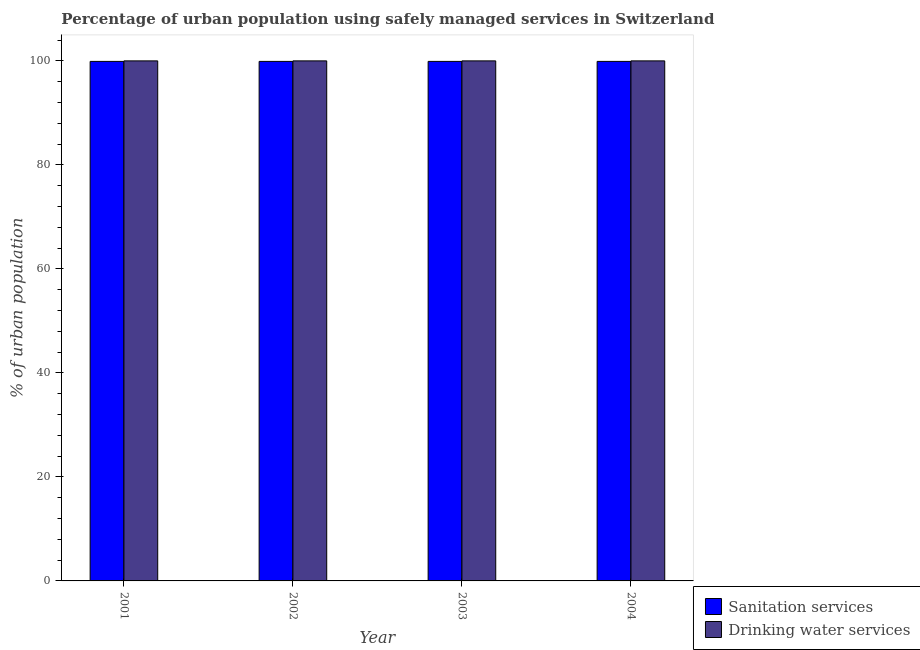How many bars are there on the 1st tick from the left?
Offer a very short reply. 2. What is the label of the 3rd group of bars from the left?
Make the answer very short. 2003. In how many cases, is the number of bars for a given year not equal to the number of legend labels?
Keep it short and to the point. 0. What is the percentage of urban population who used drinking water services in 2003?
Ensure brevity in your answer.  100. Across all years, what is the maximum percentage of urban population who used sanitation services?
Ensure brevity in your answer.  99.9. Across all years, what is the minimum percentage of urban population who used sanitation services?
Offer a terse response. 99.9. In which year was the percentage of urban population who used drinking water services minimum?
Ensure brevity in your answer.  2001. What is the total percentage of urban population who used drinking water services in the graph?
Keep it short and to the point. 400. What is the average percentage of urban population who used sanitation services per year?
Your answer should be very brief. 99.9. In how many years, is the percentage of urban population who used drinking water services greater than 40 %?
Your response must be concise. 4. Is the percentage of urban population who used drinking water services in 2001 less than that in 2003?
Keep it short and to the point. No. Is the difference between the percentage of urban population who used sanitation services in 2001 and 2004 greater than the difference between the percentage of urban population who used drinking water services in 2001 and 2004?
Give a very brief answer. No. What does the 2nd bar from the left in 2001 represents?
Provide a short and direct response. Drinking water services. What does the 2nd bar from the right in 2001 represents?
Your answer should be very brief. Sanitation services. Does the graph contain grids?
Your answer should be very brief. No. Where does the legend appear in the graph?
Provide a short and direct response. Bottom right. How many legend labels are there?
Ensure brevity in your answer.  2. What is the title of the graph?
Give a very brief answer. Percentage of urban population using safely managed services in Switzerland. Does "Non-residents" appear as one of the legend labels in the graph?
Ensure brevity in your answer.  No. What is the label or title of the Y-axis?
Provide a succinct answer. % of urban population. What is the % of urban population of Sanitation services in 2001?
Your response must be concise. 99.9. What is the % of urban population of Sanitation services in 2002?
Make the answer very short. 99.9. What is the % of urban population in Sanitation services in 2003?
Ensure brevity in your answer.  99.9. What is the % of urban population of Sanitation services in 2004?
Provide a succinct answer. 99.9. Across all years, what is the maximum % of urban population in Sanitation services?
Ensure brevity in your answer.  99.9. Across all years, what is the maximum % of urban population in Drinking water services?
Ensure brevity in your answer.  100. Across all years, what is the minimum % of urban population in Sanitation services?
Your response must be concise. 99.9. Across all years, what is the minimum % of urban population in Drinking water services?
Your answer should be very brief. 100. What is the total % of urban population in Sanitation services in the graph?
Your answer should be compact. 399.6. What is the total % of urban population of Drinking water services in the graph?
Your answer should be compact. 400. What is the difference between the % of urban population in Drinking water services in 2001 and that in 2002?
Ensure brevity in your answer.  0. What is the difference between the % of urban population of Sanitation services in 2001 and that in 2003?
Your answer should be compact. 0. What is the difference between the % of urban population of Drinking water services in 2001 and that in 2003?
Keep it short and to the point. 0. What is the difference between the % of urban population of Drinking water services in 2001 and that in 2004?
Ensure brevity in your answer.  0. What is the difference between the % of urban population in Drinking water services in 2002 and that in 2004?
Your answer should be compact. 0. What is the difference between the % of urban population of Sanitation services in 2001 and the % of urban population of Drinking water services in 2002?
Ensure brevity in your answer.  -0.1. What is the difference between the % of urban population of Sanitation services in 2001 and the % of urban population of Drinking water services in 2003?
Ensure brevity in your answer.  -0.1. What is the difference between the % of urban population in Sanitation services in 2002 and the % of urban population in Drinking water services in 2003?
Give a very brief answer. -0.1. What is the difference between the % of urban population in Sanitation services in 2002 and the % of urban population in Drinking water services in 2004?
Offer a very short reply. -0.1. What is the average % of urban population of Sanitation services per year?
Give a very brief answer. 99.9. In the year 2002, what is the difference between the % of urban population in Sanitation services and % of urban population in Drinking water services?
Your answer should be very brief. -0.1. What is the ratio of the % of urban population in Sanitation services in 2001 to that in 2002?
Provide a succinct answer. 1. What is the ratio of the % of urban population in Sanitation services in 2001 to that in 2003?
Give a very brief answer. 1. What is the ratio of the % of urban population in Sanitation services in 2002 to that in 2003?
Your answer should be very brief. 1. What is the ratio of the % of urban population of Drinking water services in 2002 to that in 2003?
Your answer should be compact. 1. What is the ratio of the % of urban population of Sanitation services in 2002 to that in 2004?
Give a very brief answer. 1. What is the ratio of the % of urban population in Drinking water services in 2002 to that in 2004?
Keep it short and to the point. 1. What is the ratio of the % of urban population of Drinking water services in 2003 to that in 2004?
Provide a short and direct response. 1. 